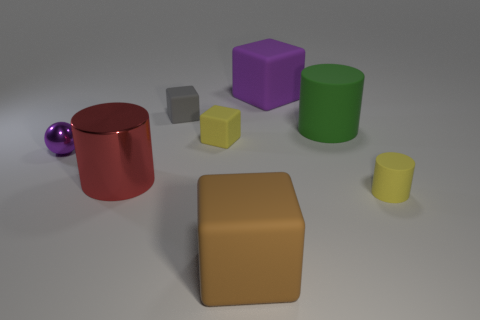Are there any brown cubes behind the large cube left of the large purple matte thing?
Provide a short and direct response. No. Is the number of small rubber objects that are behind the small yellow cube the same as the number of tiny rubber blocks?
Your response must be concise. No. How many big green matte things are in front of the rubber cylinder in front of the metal object on the left side of the large red cylinder?
Provide a short and direct response. 0. Are there any rubber cylinders of the same size as the purple ball?
Give a very brief answer. Yes. Is the number of large red metallic cylinders on the left side of the small purple ball less than the number of tiny rubber things?
Your answer should be very brief. Yes. There is a small yellow thing left of the big block behind the yellow thing on the left side of the small yellow cylinder; what is it made of?
Offer a very short reply. Rubber. Are there more large green rubber things behind the tiny gray thing than yellow rubber things right of the small yellow rubber cylinder?
Offer a very short reply. No. How many metal things are either tiny purple objects or big red cylinders?
Ensure brevity in your answer.  2. The big thing that is the same color as the small metallic ball is what shape?
Your answer should be very brief. Cube. What material is the cylinder that is in front of the shiny cylinder?
Make the answer very short. Rubber. 